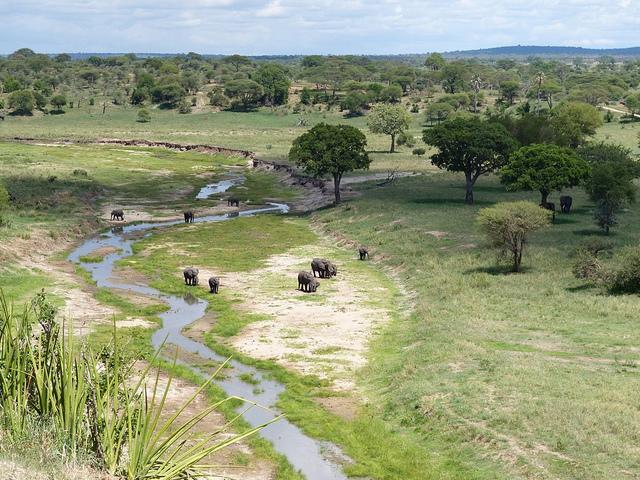Which animals are in the background?
Concise answer only. Elephants. How many elephants are there?
Keep it brief. 8. Is there water present on the field?
Keep it brief. Yes. Is this a cloudy day?
Short answer required. Yes. 